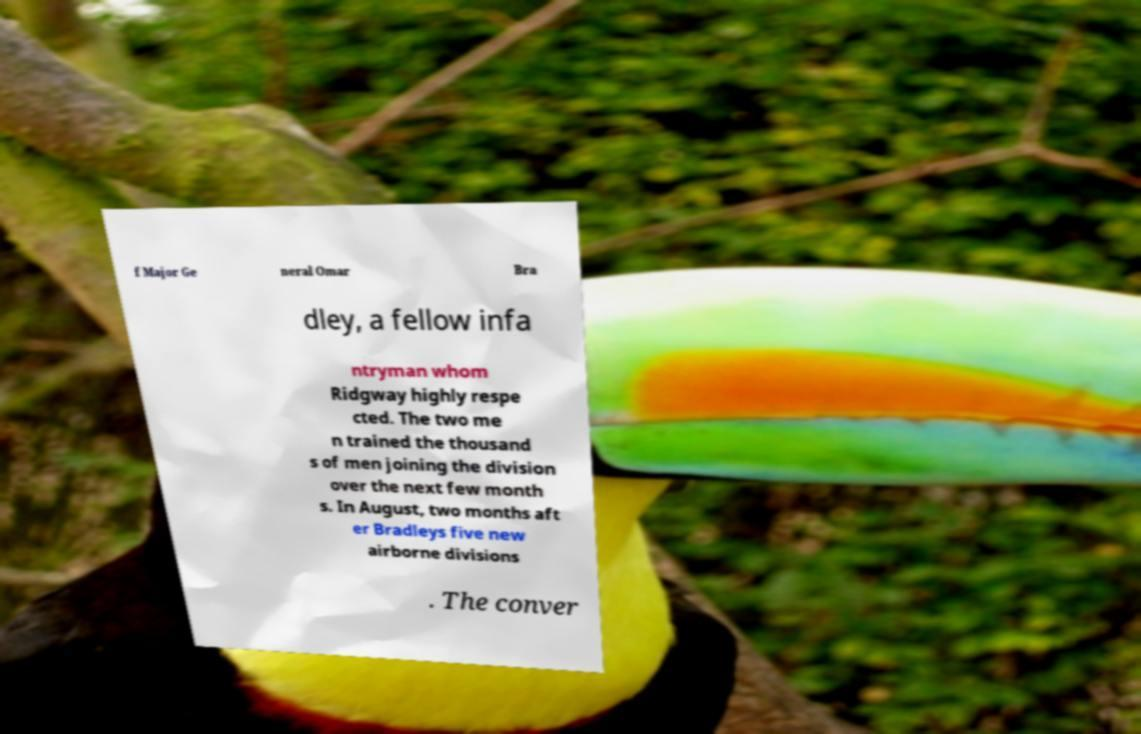There's text embedded in this image that I need extracted. Can you transcribe it verbatim? f Major Ge neral Omar Bra dley, a fellow infa ntryman whom Ridgway highly respe cted. The two me n trained the thousand s of men joining the division over the next few month s. In August, two months aft er Bradleys five new airborne divisions . The conver 